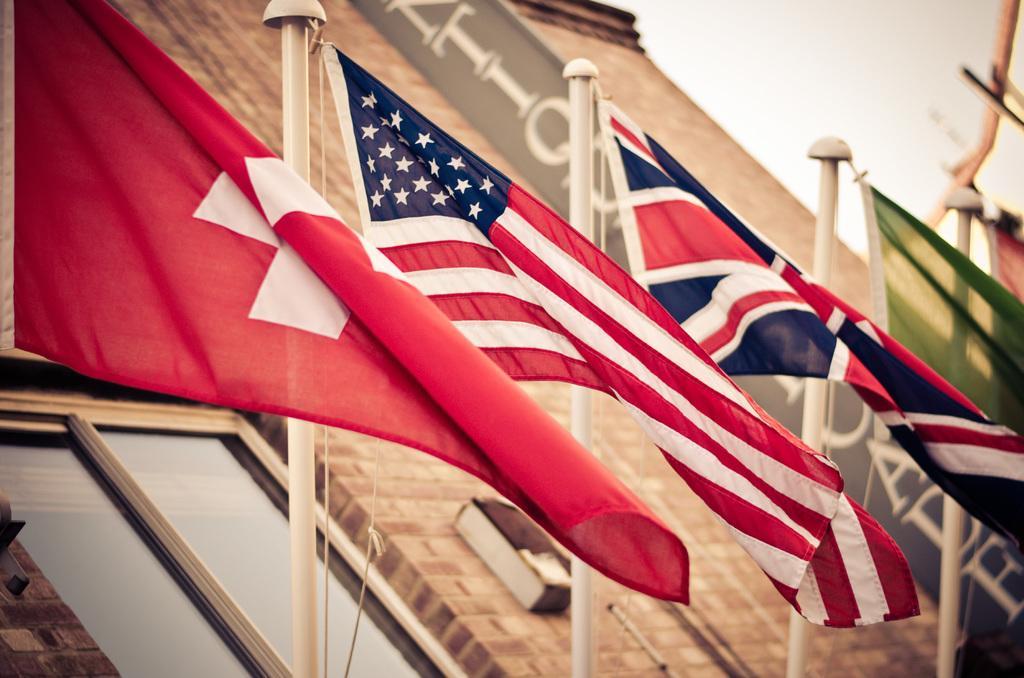Describe this image in one or two sentences. In the image we can see the flags attached to the poles and ropes. Here we can see the window, banner and text on the banner, and the sky. 